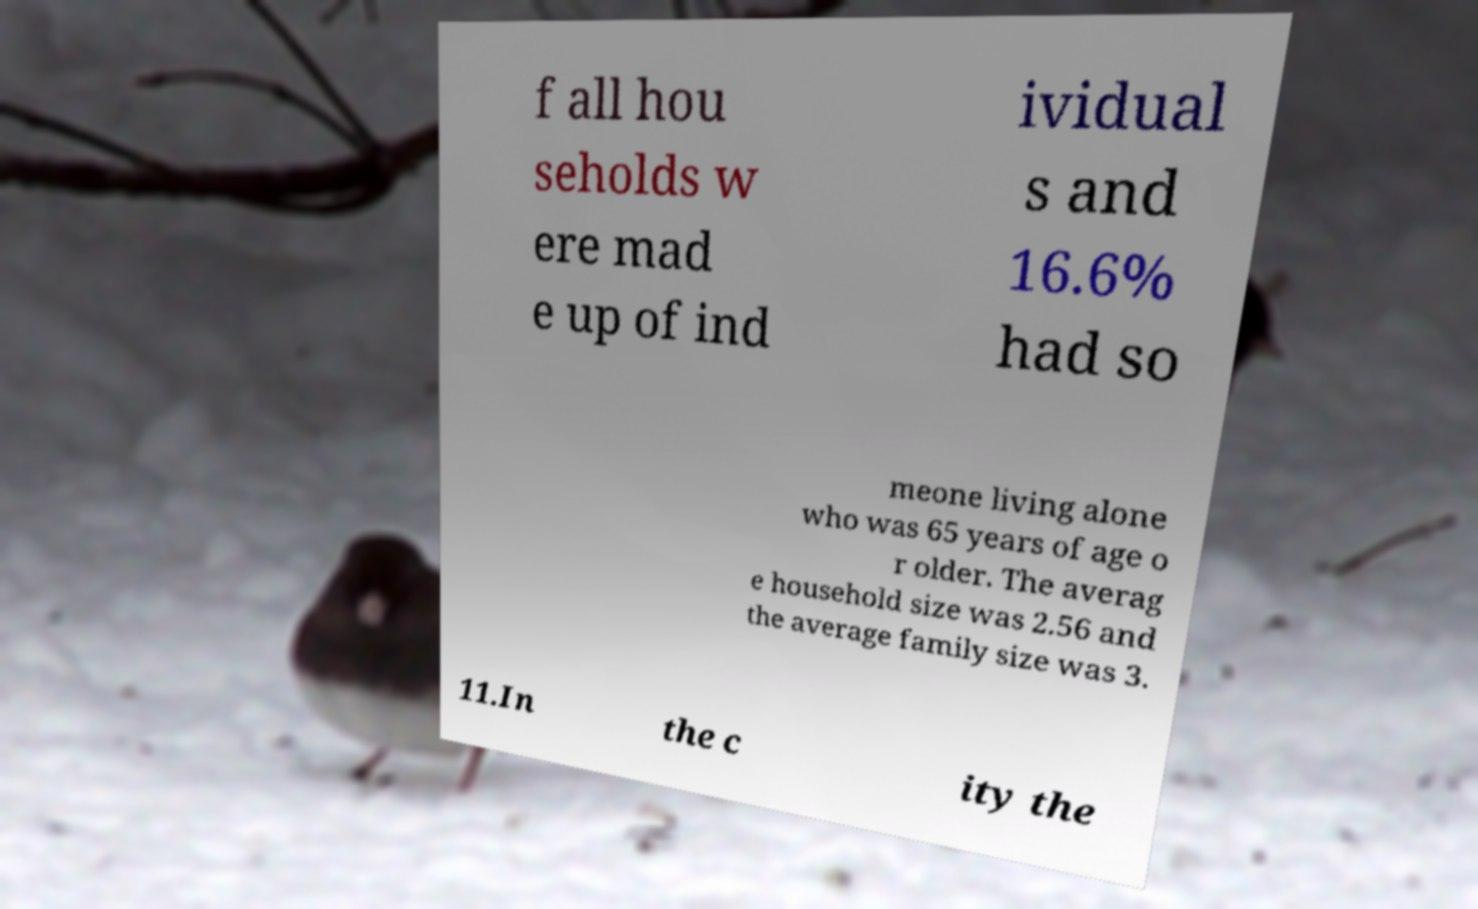There's text embedded in this image that I need extracted. Can you transcribe it verbatim? f all hou seholds w ere mad e up of ind ividual s and 16.6% had so meone living alone who was 65 years of age o r older. The averag e household size was 2.56 and the average family size was 3. 11.In the c ity the 